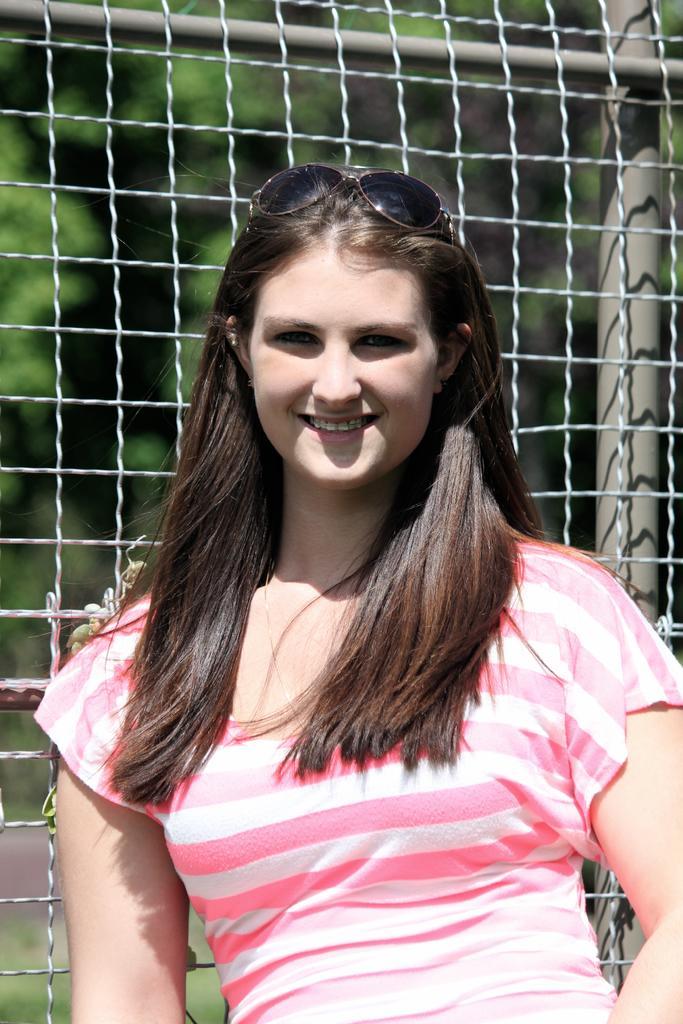In one or two sentences, can you explain what this image depicts? In this image a lady is standing wearing pink and white striped t-shirt, sunglasses. She is smiling. Behind her there is a net. In the background there are trees. 